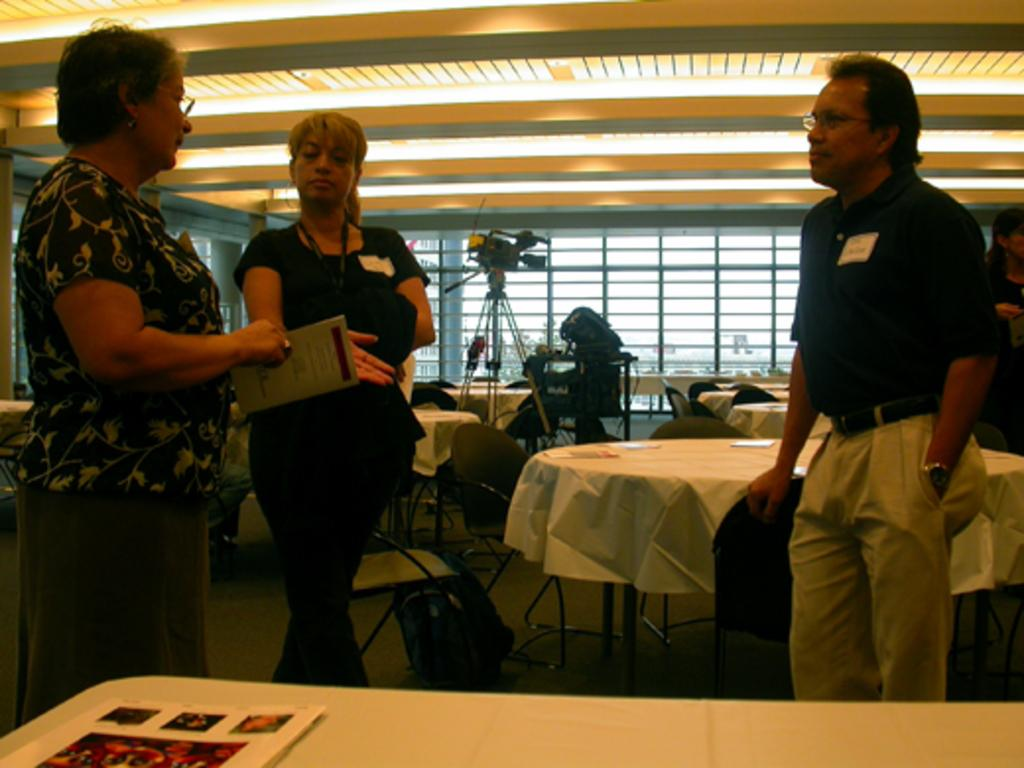How many people are in the image? There are two women and a man standing in the image, making a total of three people. Can you describe any accessories they are wearing? Two of them are wearing glasses. What can be seen in the background of the image? There are tables, chairs, and a camera in the background of the image. How many bikes are parked next to the chairs in the image? There are no bikes visible in the image; only tables, chairs, and a camera can be seen in the background. What type of metal is the camera made of in the image? The image does not provide information about the material the camera is made of, so it cannot be determined from the image. 